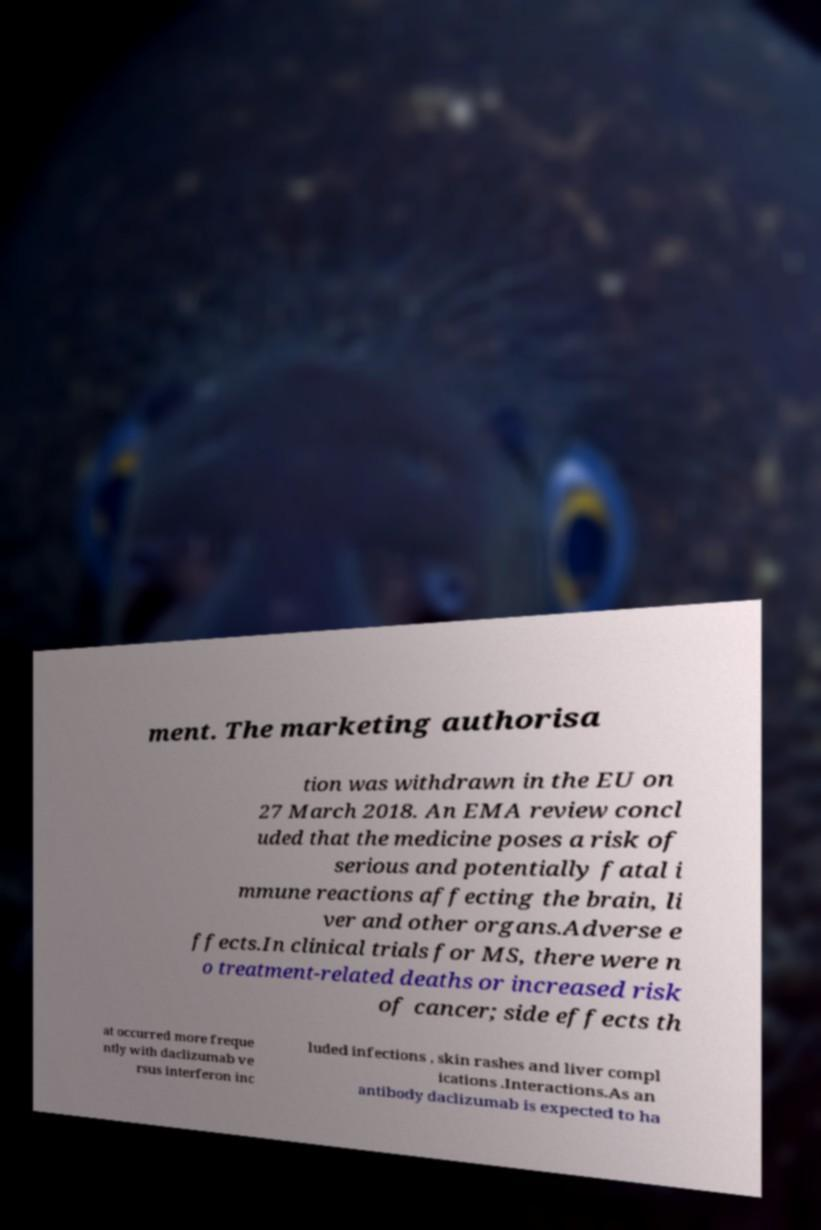Can you accurately transcribe the text from the provided image for me? ment. The marketing authorisa tion was withdrawn in the EU on 27 March 2018. An EMA review concl uded that the medicine poses a risk of serious and potentially fatal i mmune reactions affecting the brain, li ver and other organs.Adverse e ffects.In clinical trials for MS, there were n o treatment-related deaths or increased risk of cancer; side effects th at occurred more freque ntly with daclizumab ve rsus interferon inc luded infections , skin rashes and liver compl ications .Interactions.As an antibody daclizumab is expected to ha 